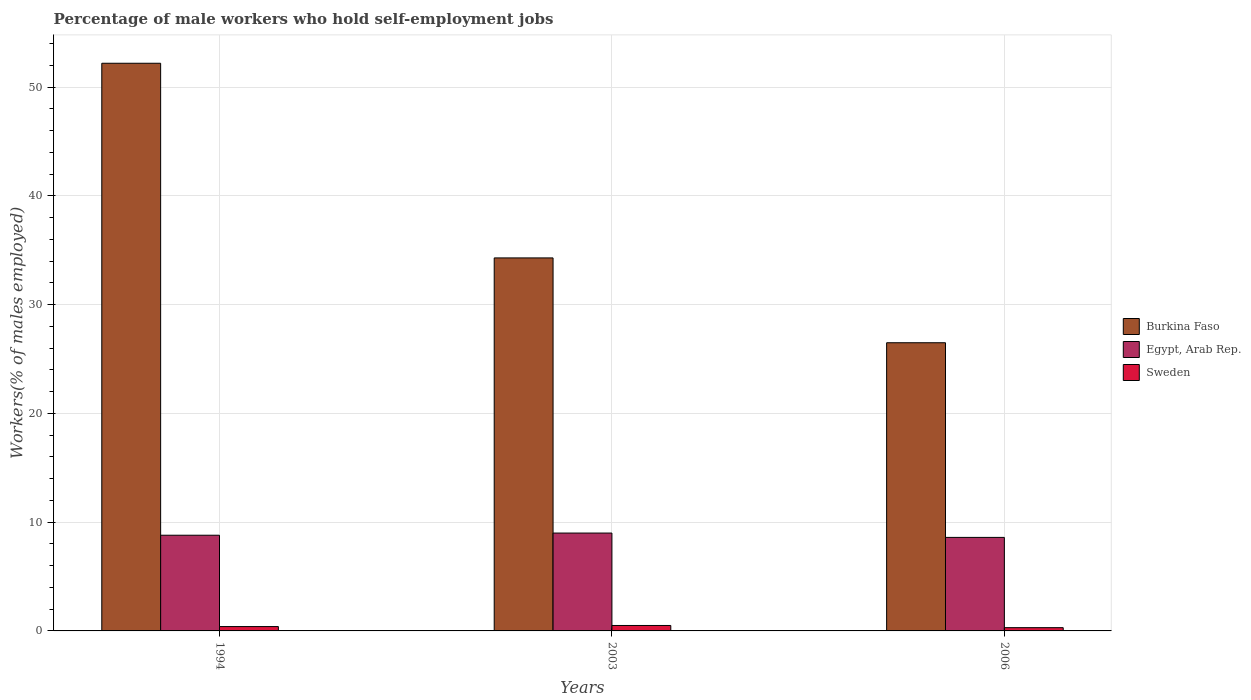How many different coloured bars are there?
Offer a terse response. 3. How many groups of bars are there?
Make the answer very short. 3. What is the percentage of self-employed male workers in Sweden in 1994?
Make the answer very short. 0.4. Across all years, what is the maximum percentage of self-employed male workers in Burkina Faso?
Give a very brief answer. 52.2. Across all years, what is the minimum percentage of self-employed male workers in Burkina Faso?
Your answer should be very brief. 26.5. What is the total percentage of self-employed male workers in Sweden in the graph?
Make the answer very short. 1.2. What is the difference between the percentage of self-employed male workers in Burkina Faso in 1994 and that in 2003?
Keep it short and to the point. 17.9. What is the difference between the percentage of self-employed male workers in Sweden in 2006 and the percentage of self-employed male workers in Burkina Faso in 1994?
Ensure brevity in your answer.  -51.9. What is the average percentage of self-employed male workers in Egypt, Arab Rep. per year?
Your answer should be very brief. 8.8. In the year 2006, what is the difference between the percentage of self-employed male workers in Egypt, Arab Rep. and percentage of self-employed male workers in Burkina Faso?
Offer a very short reply. -17.9. What is the ratio of the percentage of self-employed male workers in Egypt, Arab Rep. in 1994 to that in 2006?
Offer a very short reply. 1.02. Is the difference between the percentage of self-employed male workers in Egypt, Arab Rep. in 1994 and 2006 greater than the difference between the percentage of self-employed male workers in Burkina Faso in 1994 and 2006?
Your answer should be very brief. No. What is the difference between the highest and the second highest percentage of self-employed male workers in Burkina Faso?
Your answer should be compact. 17.9. What is the difference between the highest and the lowest percentage of self-employed male workers in Burkina Faso?
Offer a very short reply. 25.7. In how many years, is the percentage of self-employed male workers in Egypt, Arab Rep. greater than the average percentage of self-employed male workers in Egypt, Arab Rep. taken over all years?
Provide a succinct answer. 1. What does the 1st bar from the left in 2006 represents?
Your answer should be very brief. Burkina Faso. What does the 2nd bar from the right in 2003 represents?
Your answer should be compact. Egypt, Arab Rep. What is the difference between two consecutive major ticks on the Y-axis?
Offer a terse response. 10. Where does the legend appear in the graph?
Your answer should be very brief. Center right. How many legend labels are there?
Provide a succinct answer. 3. What is the title of the graph?
Give a very brief answer. Percentage of male workers who hold self-employment jobs. What is the label or title of the X-axis?
Keep it short and to the point. Years. What is the label or title of the Y-axis?
Give a very brief answer. Workers(% of males employed). What is the Workers(% of males employed) in Burkina Faso in 1994?
Your answer should be compact. 52.2. What is the Workers(% of males employed) of Egypt, Arab Rep. in 1994?
Ensure brevity in your answer.  8.8. What is the Workers(% of males employed) of Sweden in 1994?
Your answer should be very brief. 0.4. What is the Workers(% of males employed) in Burkina Faso in 2003?
Your answer should be compact. 34.3. What is the Workers(% of males employed) of Egypt, Arab Rep. in 2003?
Give a very brief answer. 9. What is the Workers(% of males employed) of Sweden in 2003?
Ensure brevity in your answer.  0.5. What is the Workers(% of males employed) in Burkina Faso in 2006?
Make the answer very short. 26.5. What is the Workers(% of males employed) of Egypt, Arab Rep. in 2006?
Keep it short and to the point. 8.6. What is the Workers(% of males employed) in Sweden in 2006?
Offer a terse response. 0.3. Across all years, what is the maximum Workers(% of males employed) in Burkina Faso?
Provide a succinct answer. 52.2. Across all years, what is the minimum Workers(% of males employed) in Burkina Faso?
Make the answer very short. 26.5. Across all years, what is the minimum Workers(% of males employed) of Egypt, Arab Rep.?
Keep it short and to the point. 8.6. Across all years, what is the minimum Workers(% of males employed) in Sweden?
Ensure brevity in your answer.  0.3. What is the total Workers(% of males employed) of Burkina Faso in the graph?
Offer a terse response. 113. What is the total Workers(% of males employed) of Egypt, Arab Rep. in the graph?
Offer a terse response. 26.4. What is the difference between the Workers(% of males employed) of Burkina Faso in 1994 and that in 2003?
Give a very brief answer. 17.9. What is the difference between the Workers(% of males employed) of Burkina Faso in 1994 and that in 2006?
Your answer should be compact. 25.7. What is the difference between the Workers(% of males employed) of Egypt, Arab Rep. in 1994 and that in 2006?
Ensure brevity in your answer.  0.2. What is the difference between the Workers(% of males employed) in Burkina Faso in 2003 and that in 2006?
Provide a succinct answer. 7.8. What is the difference between the Workers(% of males employed) in Burkina Faso in 1994 and the Workers(% of males employed) in Egypt, Arab Rep. in 2003?
Your answer should be very brief. 43.2. What is the difference between the Workers(% of males employed) of Burkina Faso in 1994 and the Workers(% of males employed) of Sweden in 2003?
Make the answer very short. 51.7. What is the difference between the Workers(% of males employed) in Egypt, Arab Rep. in 1994 and the Workers(% of males employed) in Sweden in 2003?
Your answer should be compact. 8.3. What is the difference between the Workers(% of males employed) of Burkina Faso in 1994 and the Workers(% of males employed) of Egypt, Arab Rep. in 2006?
Your response must be concise. 43.6. What is the difference between the Workers(% of males employed) of Burkina Faso in 1994 and the Workers(% of males employed) of Sweden in 2006?
Offer a very short reply. 51.9. What is the difference between the Workers(% of males employed) in Burkina Faso in 2003 and the Workers(% of males employed) in Egypt, Arab Rep. in 2006?
Ensure brevity in your answer.  25.7. What is the average Workers(% of males employed) in Burkina Faso per year?
Offer a very short reply. 37.67. What is the average Workers(% of males employed) in Egypt, Arab Rep. per year?
Your answer should be very brief. 8.8. In the year 1994, what is the difference between the Workers(% of males employed) in Burkina Faso and Workers(% of males employed) in Egypt, Arab Rep.?
Provide a succinct answer. 43.4. In the year 1994, what is the difference between the Workers(% of males employed) of Burkina Faso and Workers(% of males employed) of Sweden?
Keep it short and to the point. 51.8. In the year 1994, what is the difference between the Workers(% of males employed) of Egypt, Arab Rep. and Workers(% of males employed) of Sweden?
Make the answer very short. 8.4. In the year 2003, what is the difference between the Workers(% of males employed) in Burkina Faso and Workers(% of males employed) in Egypt, Arab Rep.?
Offer a very short reply. 25.3. In the year 2003, what is the difference between the Workers(% of males employed) of Burkina Faso and Workers(% of males employed) of Sweden?
Offer a terse response. 33.8. In the year 2003, what is the difference between the Workers(% of males employed) of Egypt, Arab Rep. and Workers(% of males employed) of Sweden?
Your response must be concise. 8.5. In the year 2006, what is the difference between the Workers(% of males employed) in Burkina Faso and Workers(% of males employed) in Egypt, Arab Rep.?
Keep it short and to the point. 17.9. In the year 2006, what is the difference between the Workers(% of males employed) of Burkina Faso and Workers(% of males employed) of Sweden?
Provide a succinct answer. 26.2. In the year 2006, what is the difference between the Workers(% of males employed) of Egypt, Arab Rep. and Workers(% of males employed) of Sweden?
Provide a short and direct response. 8.3. What is the ratio of the Workers(% of males employed) in Burkina Faso in 1994 to that in 2003?
Provide a succinct answer. 1.52. What is the ratio of the Workers(% of males employed) in Egypt, Arab Rep. in 1994 to that in 2003?
Your answer should be very brief. 0.98. What is the ratio of the Workers(% of males employed) of Sweden in 1994 to that in 2003?
Your response must be concise. 0.8. What is the ratio of the Workers(% of males employed) in Burkina Faso in 1994 to that in 2006?
Make the answer very short. 1.97. What is the ratio of the Workers(% of males employed) of Egypt, Arab Rep. in 1994 to that in 2006?
Ensure brevity in your answer.  1.02. What is the ratio of the Workers(% of males employed) in Sweden in 1994 to that in 2006?
Ensure brevity in your answer.  1.33. What is the ratio of the Workers(% of males employed) in Burkina Faso in 2003 to that in 2006?
Make the answer very short. 1.29. What is the ratio of the Workers(% of males employed) of Egypt, Arab Rep. in 2003 to that in 2006?
Keep it short and to the point. 1.05. What is the ratio of the Workers(% of males employed) in Sweden in 2003 to that in 2006?
Your answer should be compact. 1.67. What is the difference between the highest and the second highest Workers(% of males employed) of Burkina Faso?
Give a very brief answer. 17.9. What is the difference between the highest and the second highest Workers(% of males employed) in Sweden?
Your answer should be compact. 0.1. What is the difference between the highest and the lowest Workers(% of males employed) of Burkina Faso?
Offer a terse response. 25.7. What is the difference between the highest and the lowest Workers(% of males employed) of Sweden?
Make the answer very short. 0.2. 